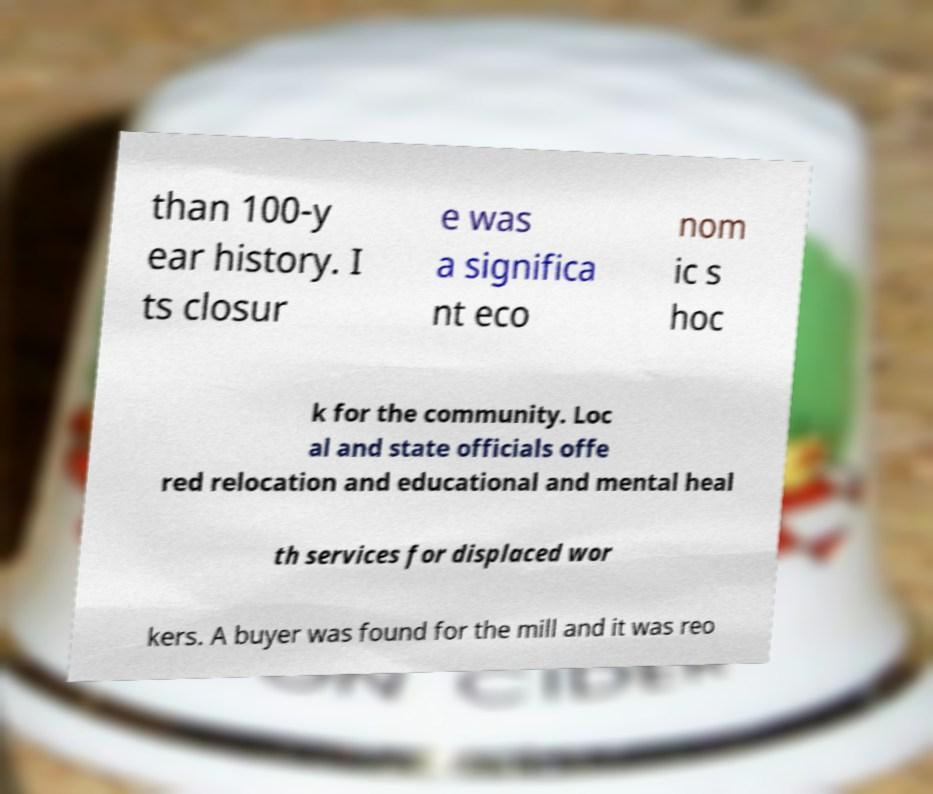Please identify and transcribe the text found in this image. than 100-y ear history. I ts closur e was a significa nt eco nom ic s hoc k for the community. Loc al and state officials offe red relocation and educational and mental heal th services for displaced wor kers. A buyer was found for the mill and it was reo 